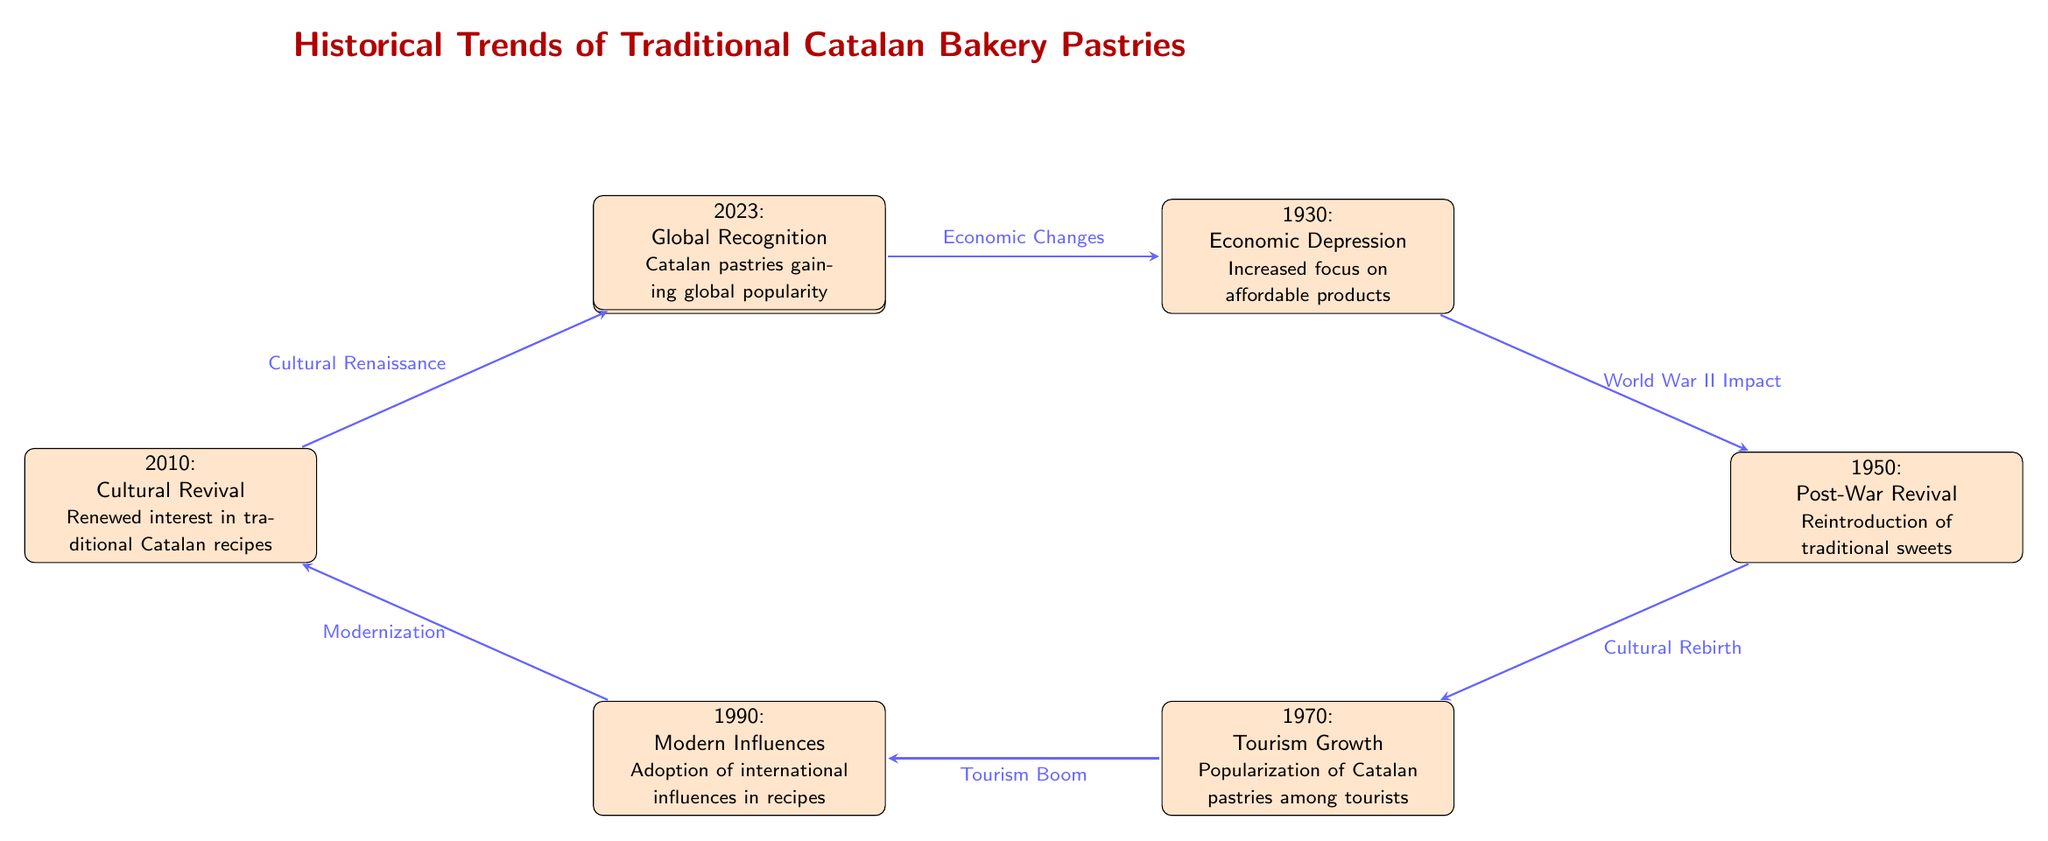What was the focus of traditional bakeries in 1900? The diagram indicates that in 1900, traditional bakeries focused on Catalan bread and simple pastries. This is found in the description of the node for that year.
Answer: Catalan bread and simple pastries Which event follows the Economic Changes in 1930? According to the diagram, the event that follows Economic Changes in 1930 is World War II Impact, leading to the node for 1950. This shows a direct transition from one event to the next.
Answer: World War II Impact How many main events are depicted in the diagram from 1900 to 2023? By counting the nodes in the diagram that represent events, there are a total of seven main events listed from 1900 to 2023. This is determined by simply counting the number of nodes.
Answer: 7 What was introduced again in 1950? The diagram specifies that in 1950, there was a Post-War Revival with a focus on the reintroduction of traditional sweets, as seen in the event description.
Answer: Traditional sweets What did Tourism Growth in 1970 lead to? The diagram shows that Tourism Growth in 1970 led to the popularization of Catalan pastries among tourists, connecting the nodes for these events. This is identified from the description following the node for 1970.
Answer: Popularization of Catalan pastries What type of influence was observed in 1990? The node for 1990 states that there was an adoption of international influences in recipes, clearly specifying the type of influence during that year.
Answer: International influences Which event occurred as a part of the Cultural Renaissance in 2023? The diagram outlines that in 2023, the event reflects Global Recognition, indicating that Catalan pastries were gaining popularity on a global scale, as depicted in the event's description.
Answer: Global Recognition What was the effect of the Cultural Revival in 2010? The diagram shows that the Cultural Revival in 2010 resulted in a renewed interest in traditional Catalan recipes, which can be determined from the transition connected to that node.
Answer: Renewed interest in traditional Catalan recipes 